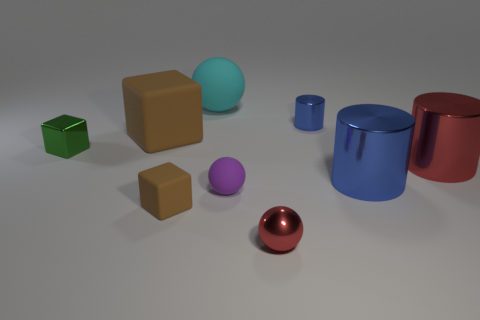Which objects in the image are closest to the foreground? The small green matte cube and the small red sphere appear to be the closest objects to the foreground in this image. 